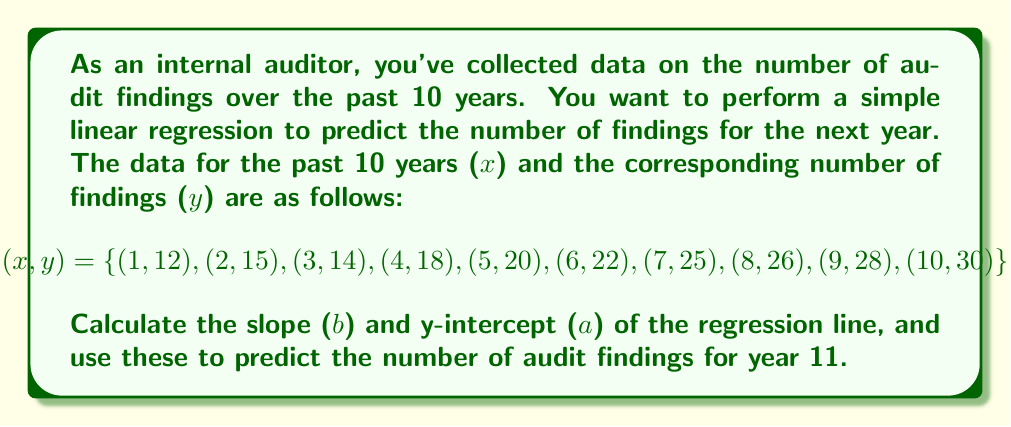Provide a solution to this math problem. To perform a simple linear regression, we need to calculate the slope (b) and y-intercept (a) of the line of best fit. We'll use the following formulas:

1. Slope (b): 
   $$b = \frac{n\sum xy - \sum x \sum y}{n\sum x^2 - (\sum x)^2}$$

2. Y-intercept (a):
   $$a = \bar{y} - b\bar{x}$$

Where $\bar{x}$ and $\bar{y}$ are the means of x and y respectively.

Step 1: Calculate the required sums and means:
$\sum x = 55$
$\sum y = 210$
$\sum xy = 1,375$
$\sum x^2 = 385$
$n = 10$
$\bar{x} = 5.5$
$\bar{y} = 21$

Step 2: Calculate the slope (b):
$$b = \frac{10(1,375) - 55(210)}{10(385) - 55^2} = \frac{13,750 - 11,550}{3,850 - 3,025} = \frac{2,200}{825} = 2.67$$

Step 3: Calculate the y-intercept (a):
$$a = 21 - 2.67(5.5) = 21 - 14.67 = 6.33$$

Step 4: Form the regression equation:
$$y = 6.33 + 2.67x$$

Step 5: Predict the number of audit findings for year 11:
$$y = 6.33 + 2.67(11) = 6.33 + 29.37 = 35.7$$

Therefore, the predicted number of audit findings for year 11 is approximately 36 (rounded to the nearest whole number).
Answer: 36 audit findings 